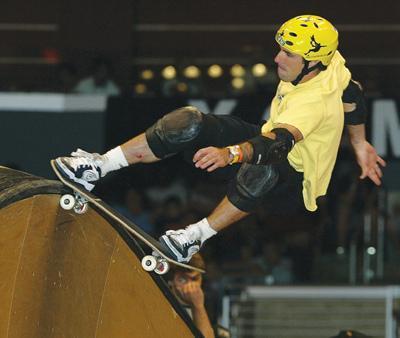How many people are skateboarding in this photo?
Give a very brief answer. 1. How many animals appear in this picture?
Give a very brief answer. 0. 